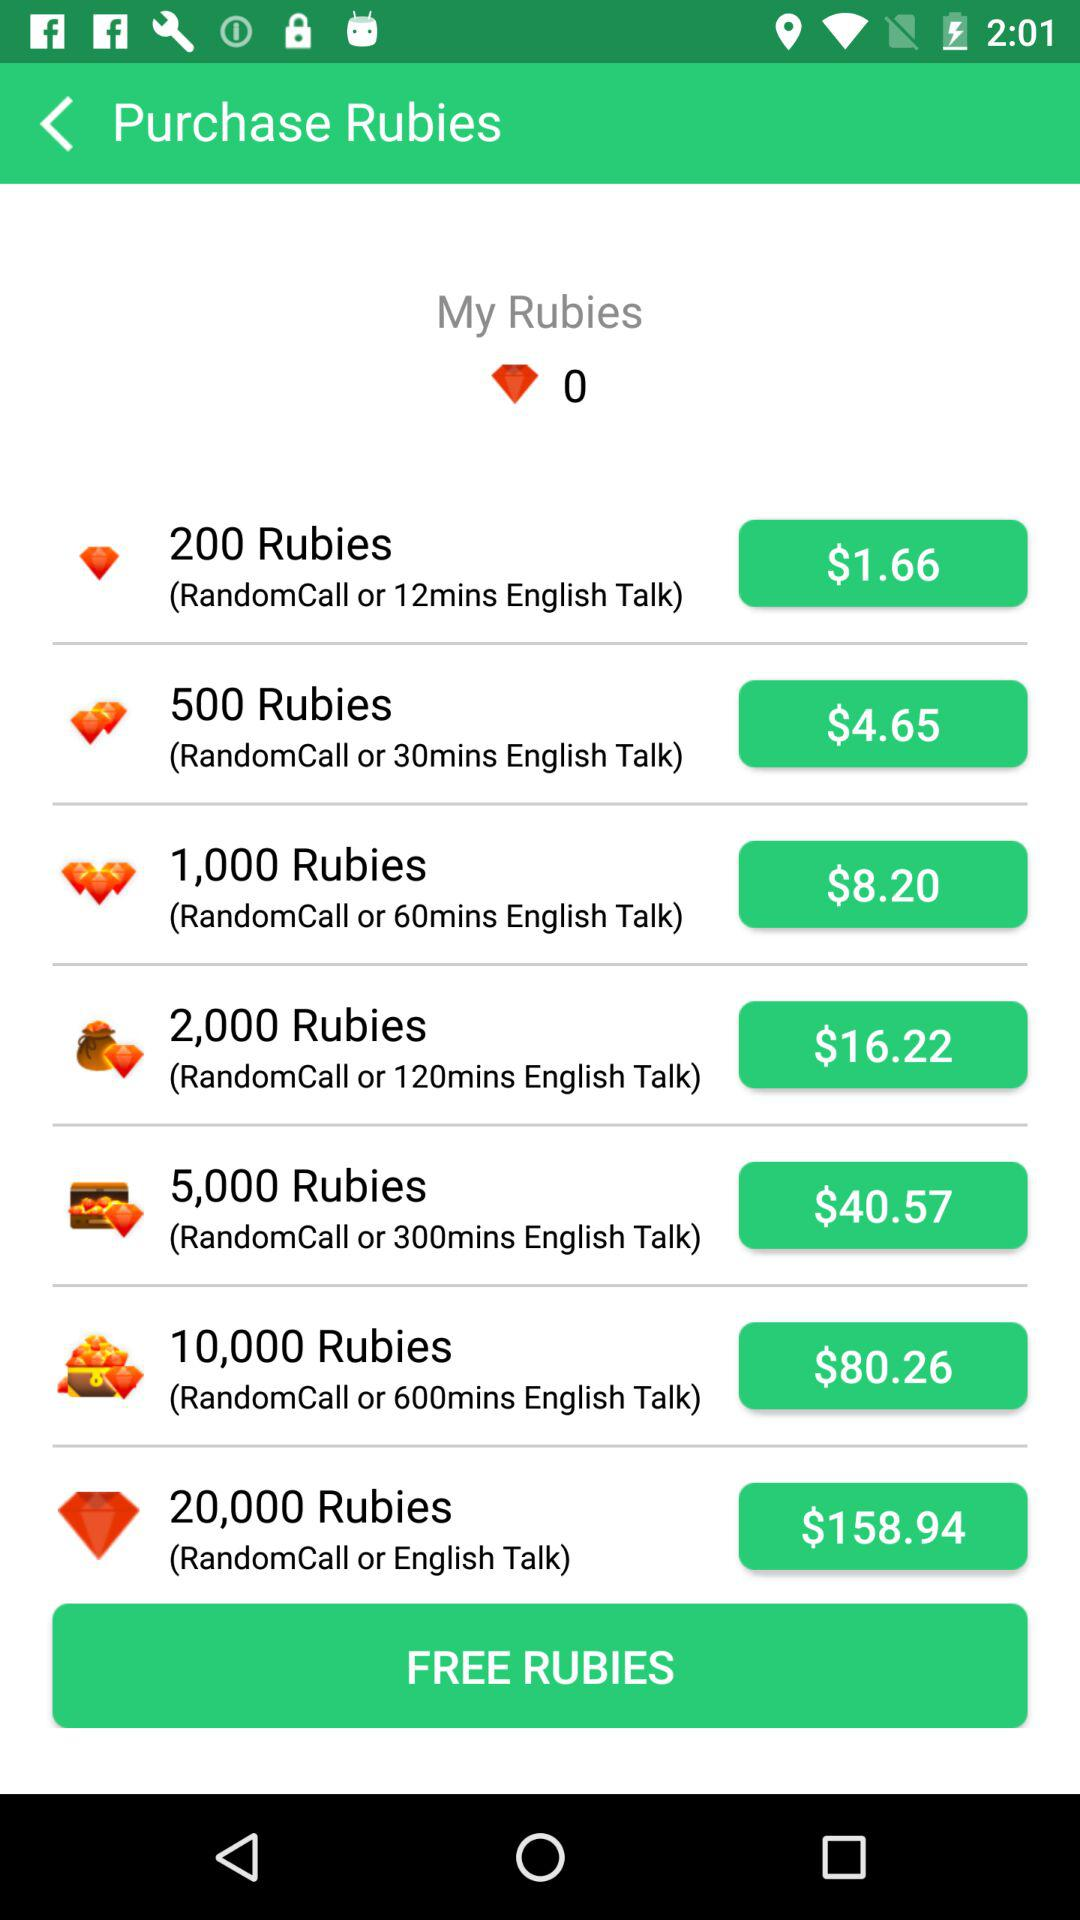For $158.94, how much ruby do we get? You get 20,000 rubies. 